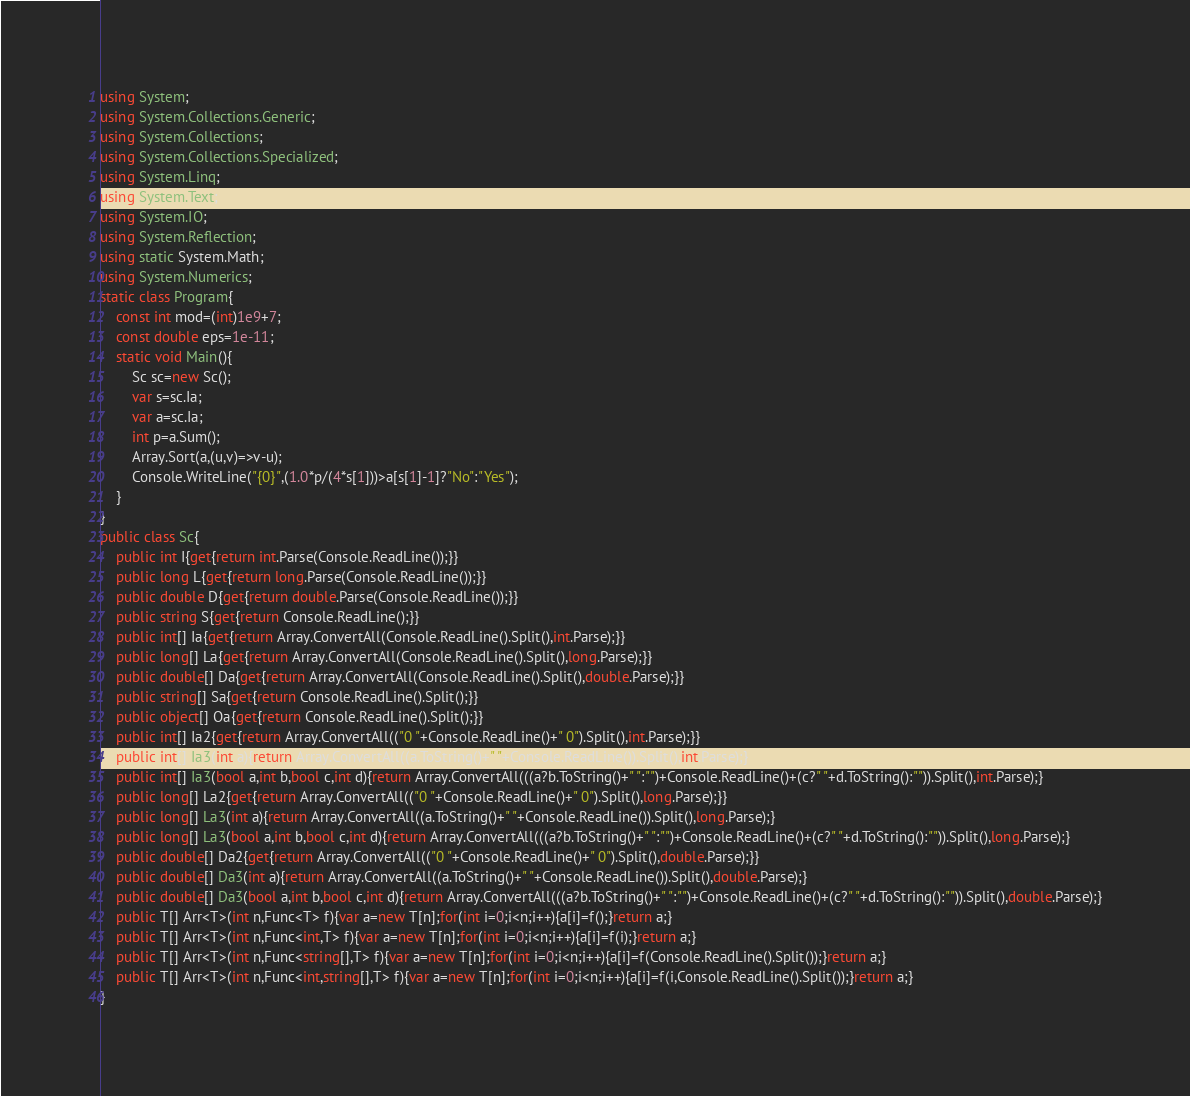<code> <loc_0><loc_0><loc_500><loc_500><_C#_>using System;
using System.Collections.Generic;
using System.Collections;
using System.Collections.Specialized;
using System.Linq;
using System.Text;
using System.IO;
using System.Reflection;
using static System.Math;
using System.Numerics;
static class Program{
	const int mod=(int)1e9+7;
	const double eps=1e-11;
	static void Main(){
		Sc sc=new Sc();
		var s=sc.Ia;
		var a=sc.Ia;
		int p=a.Sum();
		Array.Sort(a,(u,v)=>v-u);
		Console.WriteLine("{0}",(1.0*p/(4*s[1]))>a[s[1]-1]?"No":"Yes");
	}
}
public class Sc{
	public int I{get{return int.Parse(Console.ReadLine());}}
	public long L{get{return long.Parse(Console.ReadLine());}}
	public double D{get{return double.Parse(Console.ReadLine());}}
	public string S{get{return Console.ReadLine();}}
	public int[] Ia{get{return Array.ConvertAll(Console.ReadLine().Split(),int.Parse);}}
	public long[] La{get{return Array.ConvertAll(Console.ReadLine().Split(),long.Parse);}}
	public double[] Da{get{return Array.ConvertAll(Console.ReadLine().Split(),double.Parse);}}
	public string[] Sa{get{return Console.ReadLine().Split();}}
	public object[] Oa{get{return Console.ReadLine().Split();}}
	public int[] Ia2{get{return Array.ConvertAll(("0 "+Console.ReadLine()+" 0").Split(),int.Parse);}}
	public int[] Ia3(int a){return Array.ConvertAll((a.ToString()+" "+Console.ReadLine()).Split(),int.Parse);}
	public int[] Ia3(bool a,int b,bool c,int d){return Array.ConvertAll(((a?b.ToString()+" ":"")+Console.ReadLine()+(c?" "+d.ToString():"")).Split(),int.Parse);}
	public long[] La2{get{return Array.ConvertAll(("0 "+Console.ReadLine()+" 0").Split(),long.Parse);}}
	public long[] La3(int a){return Array.ConvertAll((a.ToString()+" "+Console.ReadLine()).Split(),long.Parse);}
	public long[] La3(bool a,int b,bool c,int d){return Array.ConvertAll(((a?b.ToString()+" ":"")+Console.ReadLine()+(c?" "+d.ToString():"")).Split(),long.Parse);}
	public double[] Da2{get{return Array.ConvertAll(("0 "+Console.ReadLine()+" 0").Split(),double.Parse);}}
	public double[] Da3(int a){return Array.ConvertAll((a.ToString()+" "+Console.ReadLine()).Split(),double.Parse);}
	public double[] Da3(bool a,int b,bool c,int d){return Array.ConvertAll(((a?b.ToString()+" ":"")+Console.ReadLine()+(c?" "+d.ToString():"")).Split(),double.Parse);}
	public T[] Arr<T>(int n,Func<T> f){var a=new T[n];for(int i=0;i<n;i++){a[i]=f();}return a;}
	public T[] Arr<T>(int n,Func<int,T> f){var a=new T[n];for(int i=0;i<n;i++){a[i]=f(i);}return a;}
	public T[] Arr<T>(int n,Func<string[],T> f){var a=new T[n];for(int i=0;i<n;i++){a[i]=f(Console.ReadLine().Split());}return a;}
	public T[] Arr<T>(int n,Func<int,string[],T> f){var a=new T[n];for(int i=0;i<n;i++){a[i]=f(i,Console.ReadLine().Split());}return a;}
}</code> 